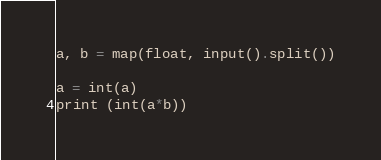<code> <loc_0><loc_0><loc_500><loc_500><_Python_>a, b = map(float, input().split())

a = int(a)
print (int(a*b))</code> 